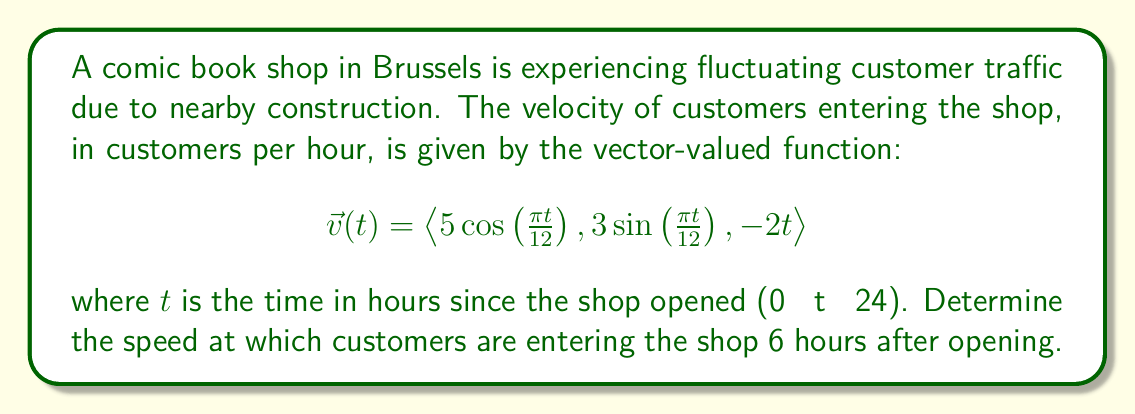Can you solve this math problem? To solve this problem, we need to follow these steps:

1) The speed of customers entering the shop is the magnitude of the velocity vector. We can calculate this using the formula:

   $$\text{Speed} = \|\vec{v}(t)\| = \sqrt{v_x^2 + v_y^2 + v_z^2}$$

2) We need to evaluate each component of $\vec{v}(t)$ at $t = 6$:

   $v_x(6) = 5\cos(\frac{\pi \cdot 6}{12}) = 5\cos(\frac{\pi}{2}) = 0$

   $v_y(6) = 3\sin(\frac{\pi \cdot 6}{12}) = 3\sin(\frac{\pi}{2}) = 3$

   $v_z(6) = -2 \cdot 6 = -12$

3) Now we can substitute these values into the speed formula:

   $$\text{Speed} = \sqrt{0^2 + 3^2 + (-12)^2}$$

4) Simplify:
   
   $$\text{Speed} = \sqrt{0 + 9 + 144} = \sqrt{153}$$

5) The final step is to simplify the square root:

   $$\text{Speed} = 3\sqrt{17}$$

Therefore, 6 hours after opening, customers are entering the shop at a speed of $3\sqrt{17}$ customers per hour.
Answer: $3\sqrt{17}$ customers per hour 